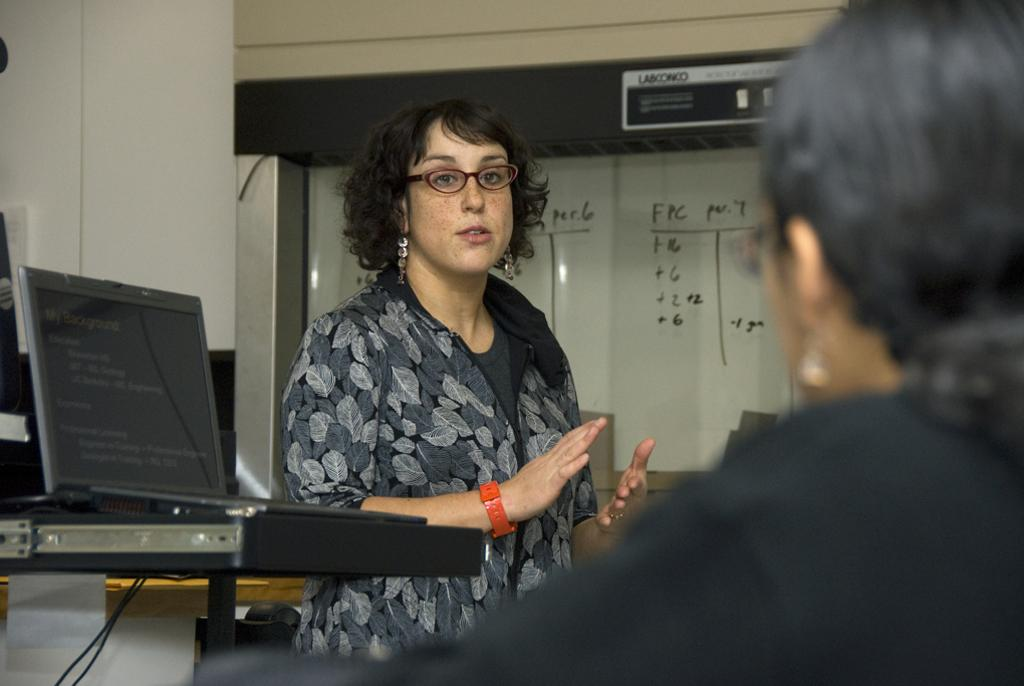What is the main subject of the image? There is a woman standing in the image. Can you describe the surroundings of the woman? There is another person in the background of the image, and there are walls visible in the image. What object can be seen on a table in the image? There is a laptop on a table in the image. What is the purpose of the board in the image? The purpose of the board in the image is not clear from the provided facts. What type of bridge can be seen in the background of the image? There is no bridge present in the image; it features a woman standing, another person in the background, walls, a laptop on a table, and a board. 